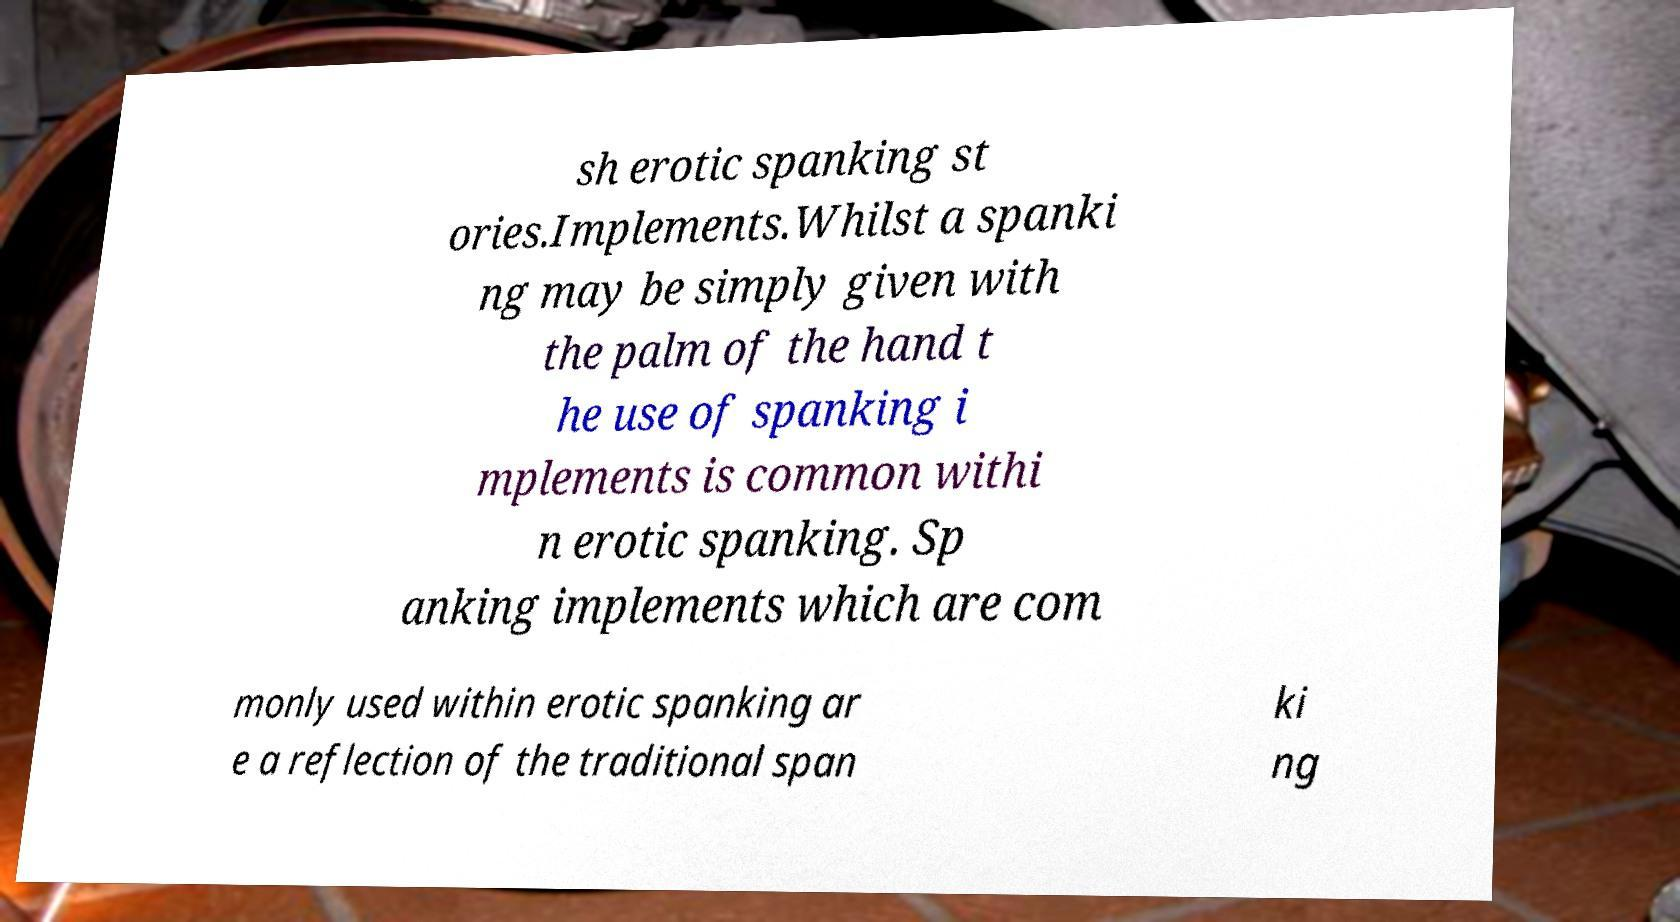For documentation purposes, I need the text within this image transcribed. Could you provide that? sh erotic spanking st ories.Implements.Whilst a spanki ng may be simply given with the palm of the hand t he use of spanking i mplements is common withi n erotic spanking. Sp anking implements which are com monly used within erotic spanking ar e a reflection of the traditional span ki ng 